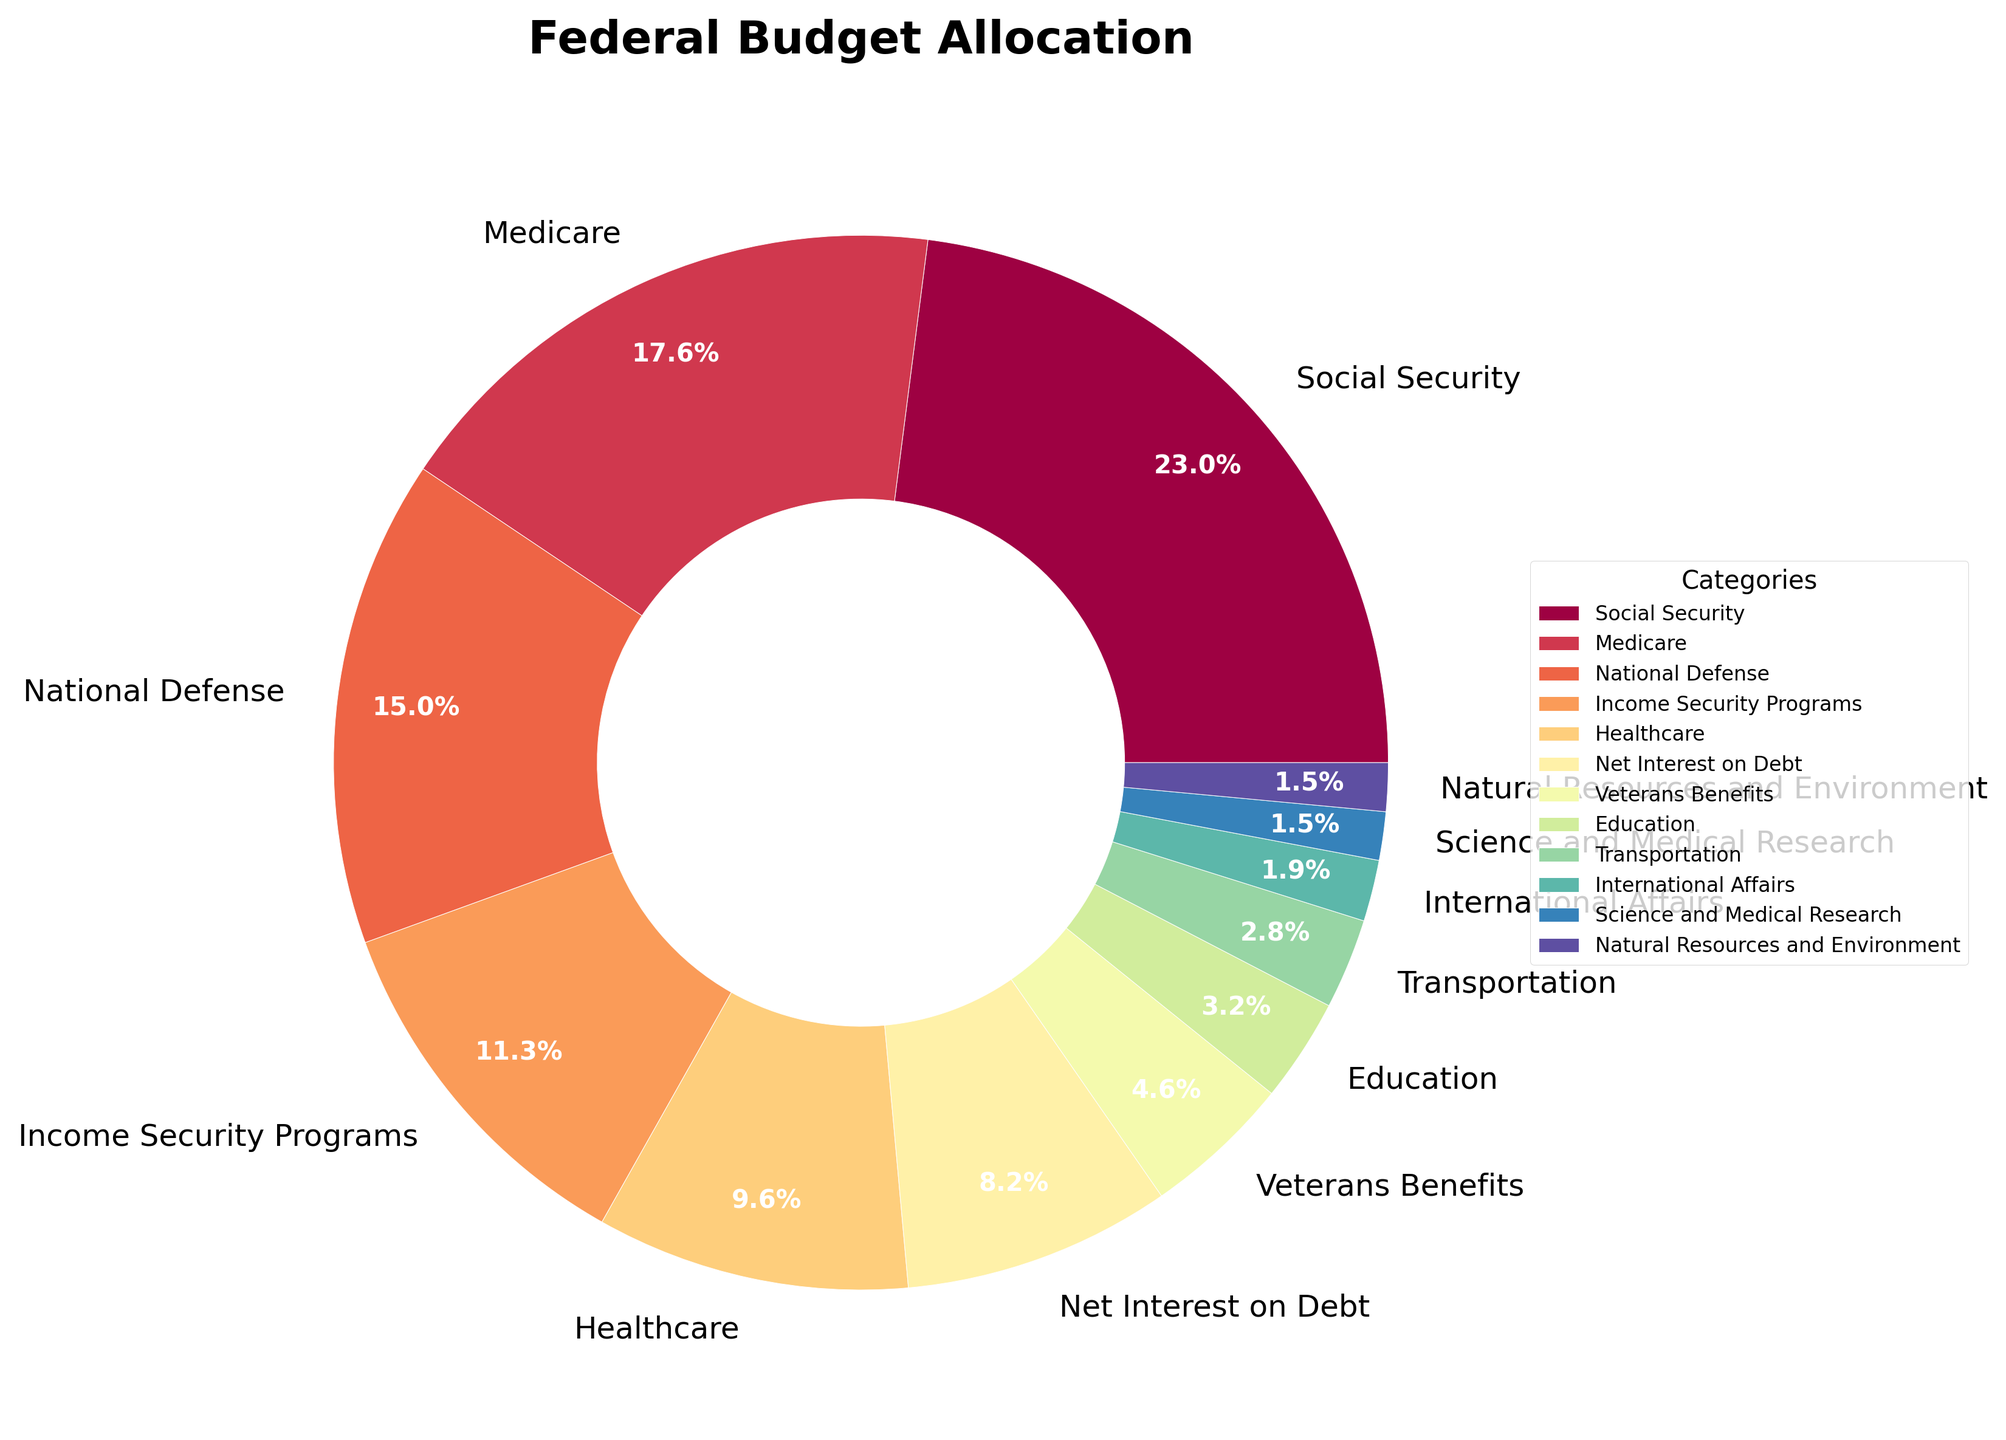Which category has the highest percentage allocation? The category with the highest percentage allocation is identified by looking at the largest segment in the pie chart. This segment is labeled "Social Security" with 23.2%.
Answer: Social Security Which two categories together make up more than one-third of the budget? Adding together the percentages of different categories, the two categories that sum to more than one-third (33.3%) are "Social Security" (23.2%) and "Medicare" (17.8%). Together, they make up 41%.
Answer: Social Security and Medicare What is the approximate combined allocation for Education and Veterans Benefits? Adding the percentages for Education (3.2%) and Veterans Benefits (4.6%), the combined allocation is 3.2 + 4.6 = 7.8%.
Answer: 7.8% What is the difference in percentage allocation between National Defense and Healthcare? Subtracting the percentage allocation of Healthcare (9.7%) from National Defense (15.1%) gives 15.1 - 9.7 = 5.4%.
Answer: 5.4% How does the allocation for Net Interest on Debt compare to that of Income Security Programs? The allocation for Net Interest on Debt is 8.3%, which is less than the 11.4% allocation for Income Security Programs.
Answer: Less Which category has the smallest allocation, and what is it? The smallest segment in the pie chart represents the "Science and Medical Research" category with an allocation of 1.5%.
Answer: Science and Medical Research What is the cumulative percentage of the categories labeled International Affairs and Natural Resources and Environment? Adding the percentages for International Affairs (1.9%) and Natural Resources and Environment (1.5%) totals 1.9 + 1.5 = 3.4%.
Answer: 3.4% Are there more categories allocated under 5% or over 10%? By counting the categories, there are 7 categories under 5% and 4 categories over 10%. So there are more categories under 5%.
Answer: Under 5% To which sector does the light-blue color segment correspond? The light-blue color in the pie chart corresponds to the "Income Security Programs" segment.
Answer: Income Security Programs 